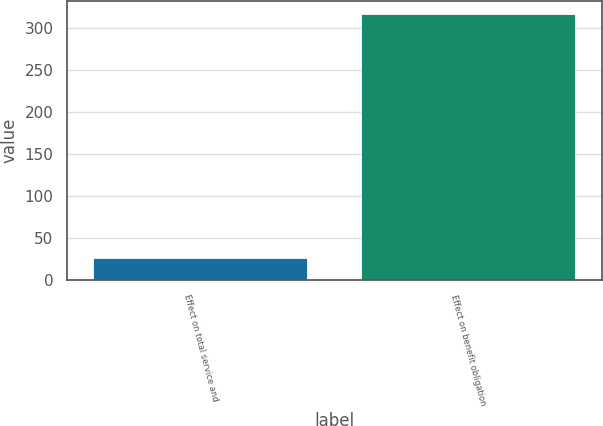Convert chart to OTSL. <chart><loc_0><loc_0><loc_500><loc_500><bar_chart><fcel>Effect on total service and<fcel>Effect on benefit obligation<nl><fcel>26.5<fcel>315.8<nl></chart> 